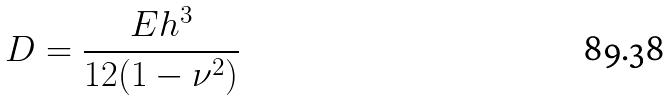Convert formula to latex. <formula><loc_0><loc_0><loc_500><loc_500>D = \frac { E h ^ { 3 } } { 1 2 ( 1 - \nu ^ { 2 } ) }</formula> 